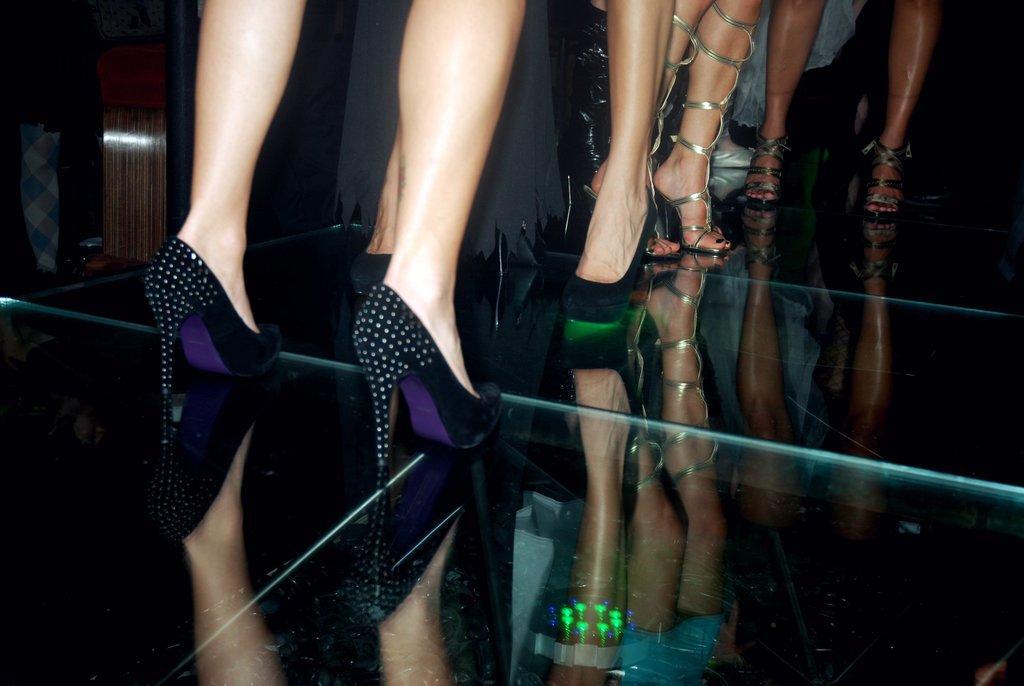Could you give a brief overview of what you see in this image? In this image, I can see the person's legs with the footwear. This looks like a glass floor. I think this is a wooden object. 